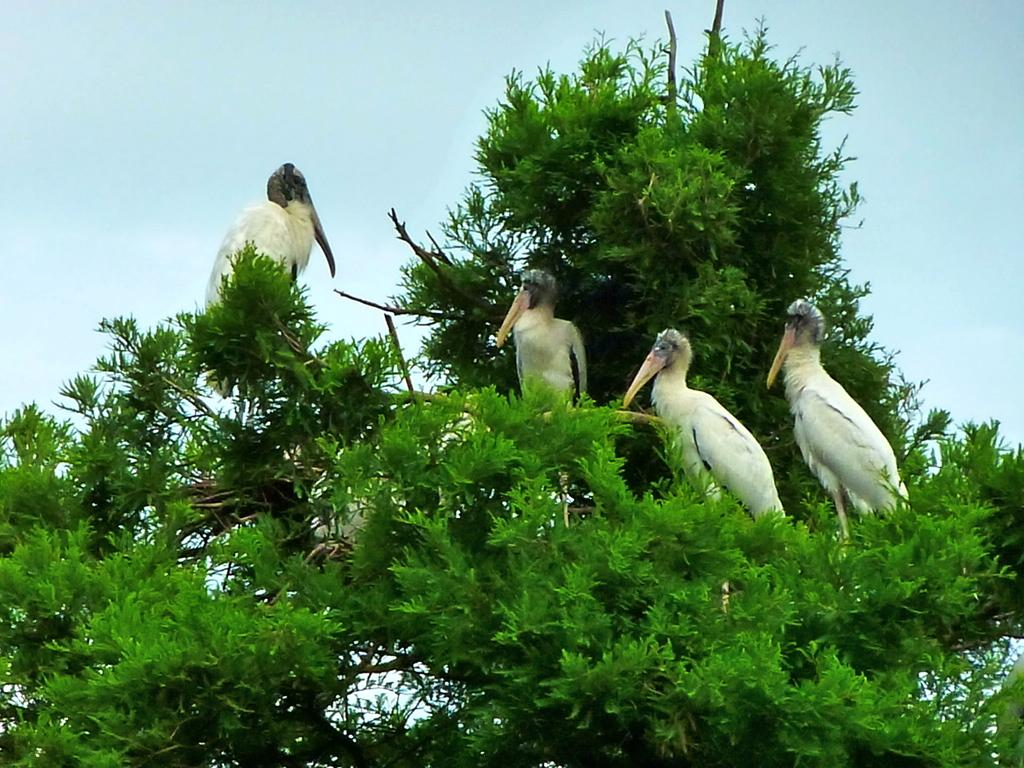What is the main object in the image? There is a tree in the image. Are there any animals on the tree? Yes, there are four white birds on the tree. What can be seen in the background of the image? The sky is visible in the background of the image. What type of bun is being used as a decoration on the tree in the image? There is no bun present in the image; it features a tree with four white birds. Can you see a train passing by in the image? There is no train visible in the image. 